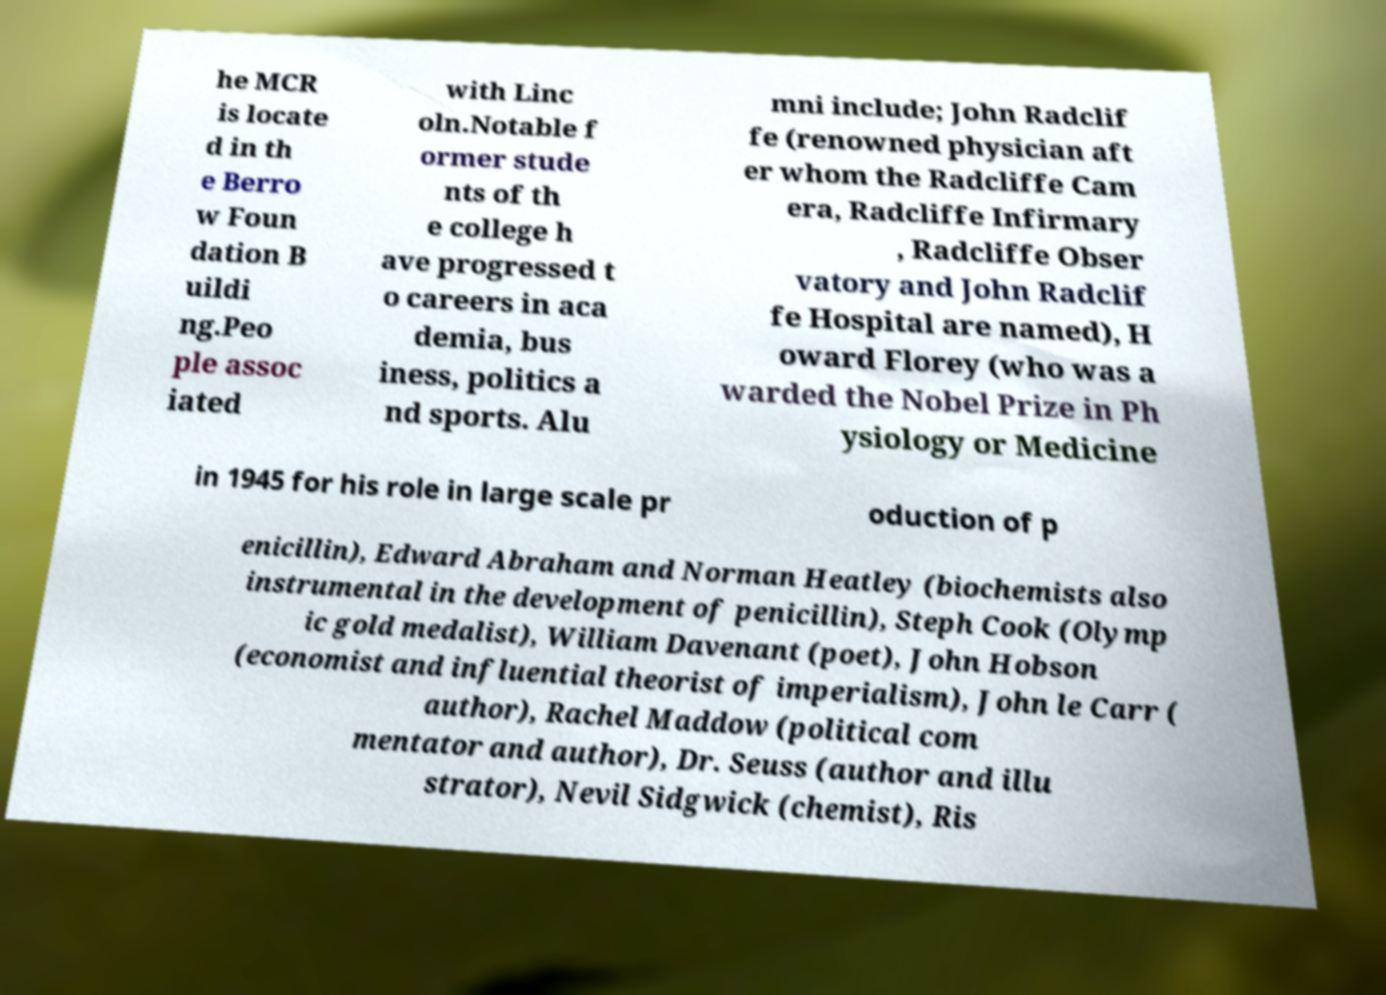Could you extract and type out the text from this image? he MCR is locate d in th e Berro w Foun dation B uildi ng.Peo ple assoc iated with Linc oln.Notable f ormer stude nts of th e college h ave progressed t o careers in aca demia, bus iness, politics a nd sports. Alu mni include; John Radclif fe (renowned physician aft er whom the Radcliffe Cam era, Radcliffe Infirmary , Radcliffe Obser vatory and John Radclif fe Hospital are named), H oward Florey (who was a warded the Nobel Prize in Ph ysiology or Medicine in 1945 for his role in large scale pr oduction of p enicillin), Edward Abraham and Norman Heatley (biochemists also instrumental in the development of penicillin), Steph Cook (Olymp ic gold medalist), William Davenant (poet), John Hobson (economist and influential theorist of imperialism), John le Carr ( author), Rachel Maddow (political com mentator and author), Dr. Seuss (author and illu strator), Nevil Sidgwick (chemist), Ris 